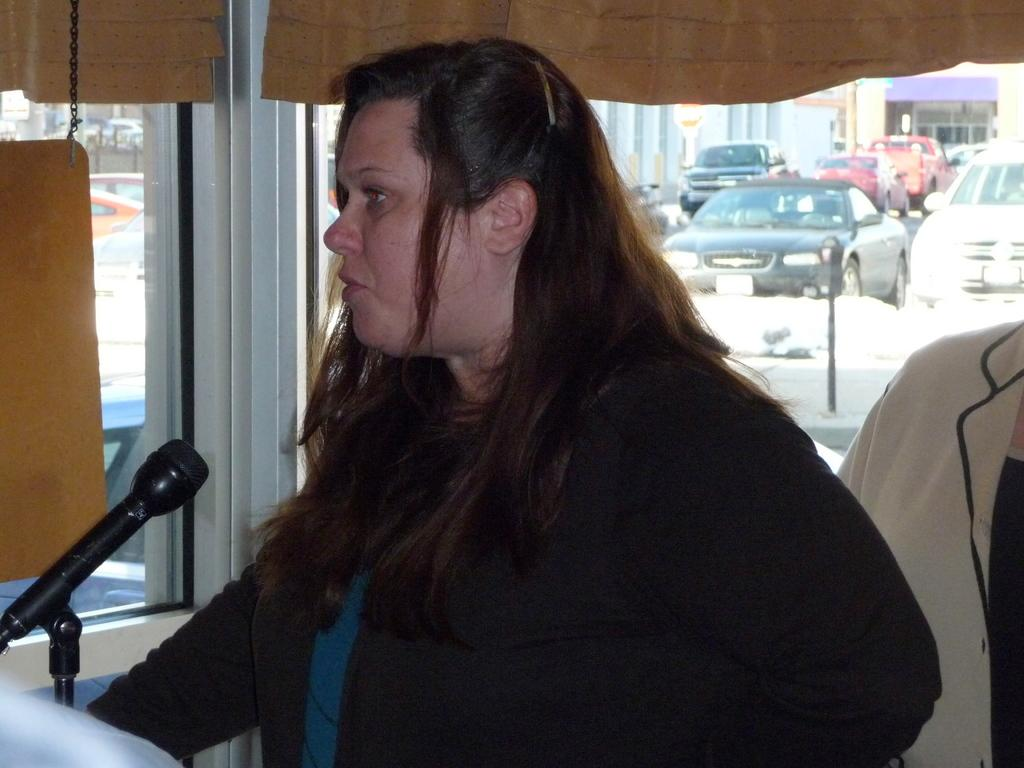Who is the main subject in the image? There is a woman in the image. What is the woman doing in the image? The woman is speaking. Can you describe the person behind the woman? There is another person behind the woman, but their appearance or actions are not clear from the provided facts. What can be seen through the window in the image? There are many vehicles outside the window. Reasoning: Let's context: Let's think step by step in order to produce the conversation. We start by identifying the main subject in the image, which is the woman. Then, we describe her actions, which are speaking. Next, we acknowledge the presence of another person in the image, but we do not make any assumptions about their appearance or actions. Finally, we describe the view outside the window, which is of many vehicles. Absurd Question/Answer: What hobbies does the woman have, as seen in the image? There is no information about the woman's hobbies in the image. Is there an alley visible through the window in the image? The provided facts do not mention an alley; only vehicles are mentioned as being visible through the window. Is there any poison visible in the image? There is no mention of poison in the image. The image features a woman speaking, another person behind her, a window with vehicles outside, and no other elements that would suggest the presence of poison. 